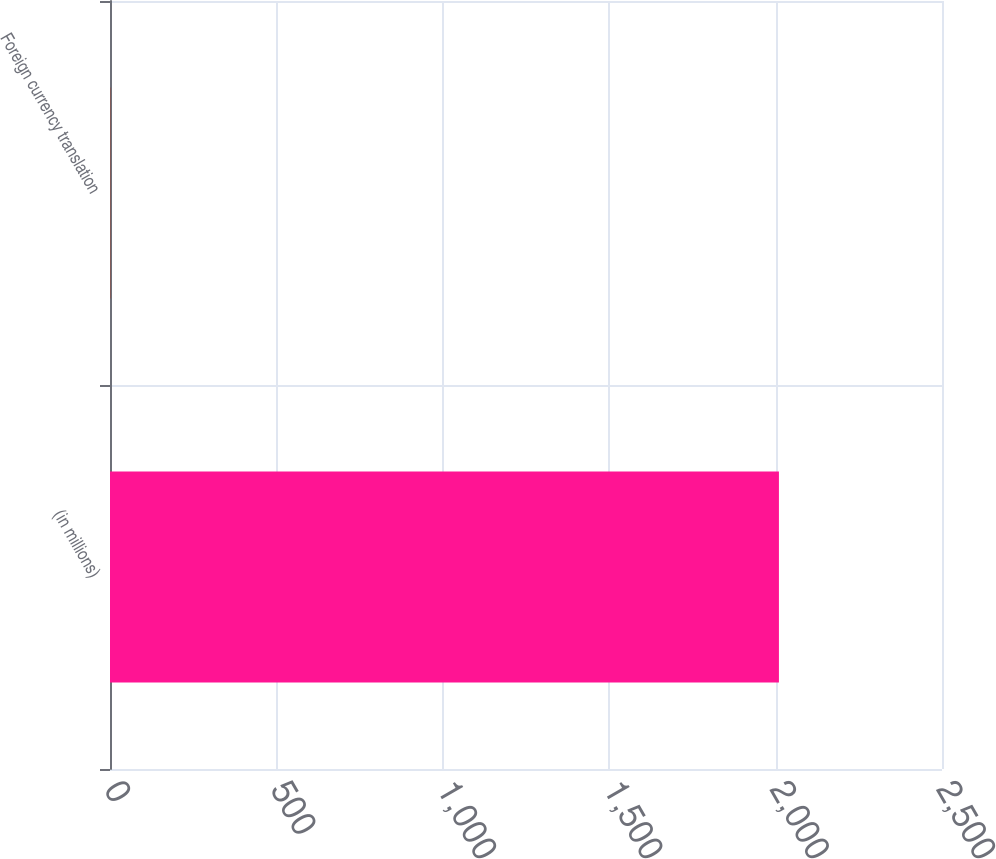<chart> <loc_0><loc_0><loc_500><loc_500><bar_chart><fcel>(in millions)<fcel>Foreign currency translation<nl><fcel>2010<fcel>1<nl></chart> 